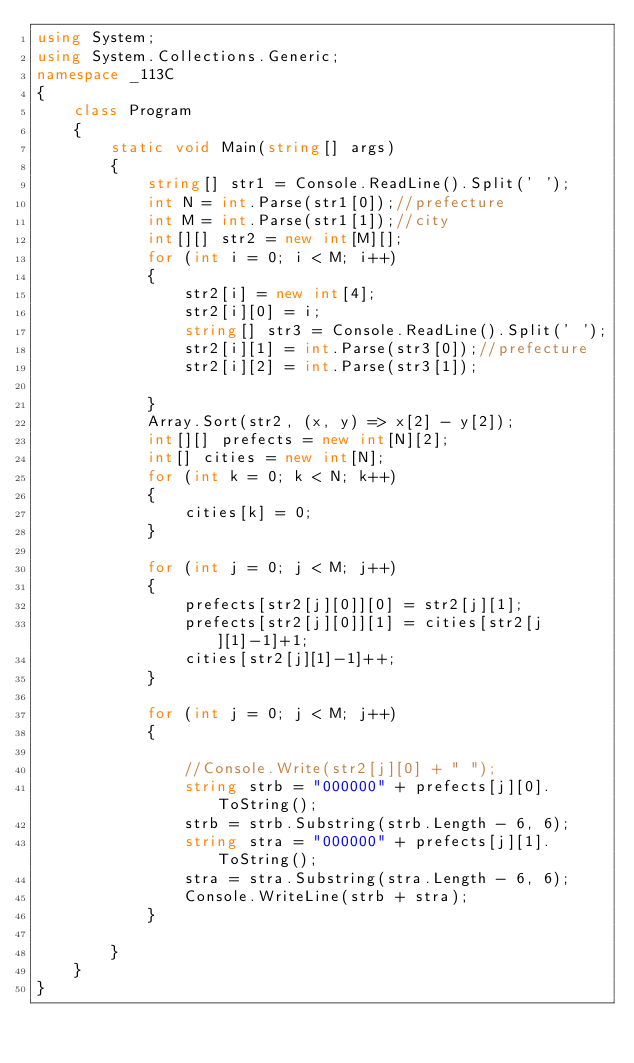<code> <loc_0><loc_0><loc_500><loc_500><_C#_>using System;
using System.Collections.Generic;
namespace _113C
{
    class Program
    {
        static void Main(string[] args)
        {
            string[] str1 = Console.ReadLine().Split(' ');
            int N = int.Parse(str1[0]);//prefecture
            int M = int.Parse(str1[1]);//city
            int[][] str2 = new int[M][];
            for (int i = 0; i < M; i++)
            {
                str2[i] = new int[4];
                str2[i][0] = i;
                string[] str3 = Console.ReadLine().Split(' ');
                str2[i][1] = int.Parse(str3[0]);//prefecture
                str2[i][2] = int.Parse(str3[1]);

            }
            Array.Sort(str2, (x, y) => x[2] - y[2]);
            int[][] prefects = new int[N][2];
            int[] cities = new int[N];
            for (int k = 0; k < N; k++)
            {
                cities[k] = 0;
            }

            for (int j = 0; j < M; j++)
            {
                prefects[str2[j][0]][0] = str2[j][1];
                prefects[str2[j][0]][1] = cities[str2[j][1]-1]+1;
                cities[str2[j][1]-1]++;
            }

            for (int j = 0; j < M; j++)
            {
                
                //Console.Write(str2[j][0] + " ");
                string strb = "000000" + prefects[j][0].ToString();
                strb = strb.Substring(strb.Length - 6, 6);
                string stra = "000000" + prefects[j][1].ToString();
                stra = stra.Substring(stra.Length - 6, 6);
                Console.WriteLine(strb + stra);
            }

        }
    }
}
</code> 